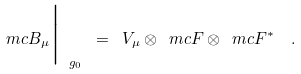<formula> <loc_0><loc_0><loc_500><loc_500>\ m c { B } _ { \mu } \Big | _ { \ g _ { 0 } } \ = \ V _ { \mu } \otimes \ m c { F } \otimes \ m c { F } ^ { \ast } \ \ .</formula> 